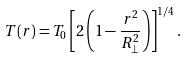<formula> <loc_0><loc_0><loc_500><loc_500>T ( r ) = T _ { 0 } \left [ 2 \left ( 1 - \frac { r ^ { 2 } } { R _ { \perp } ^ { 2 } } \right ) \right ] ^ { 1 / 4 } .</formula> 